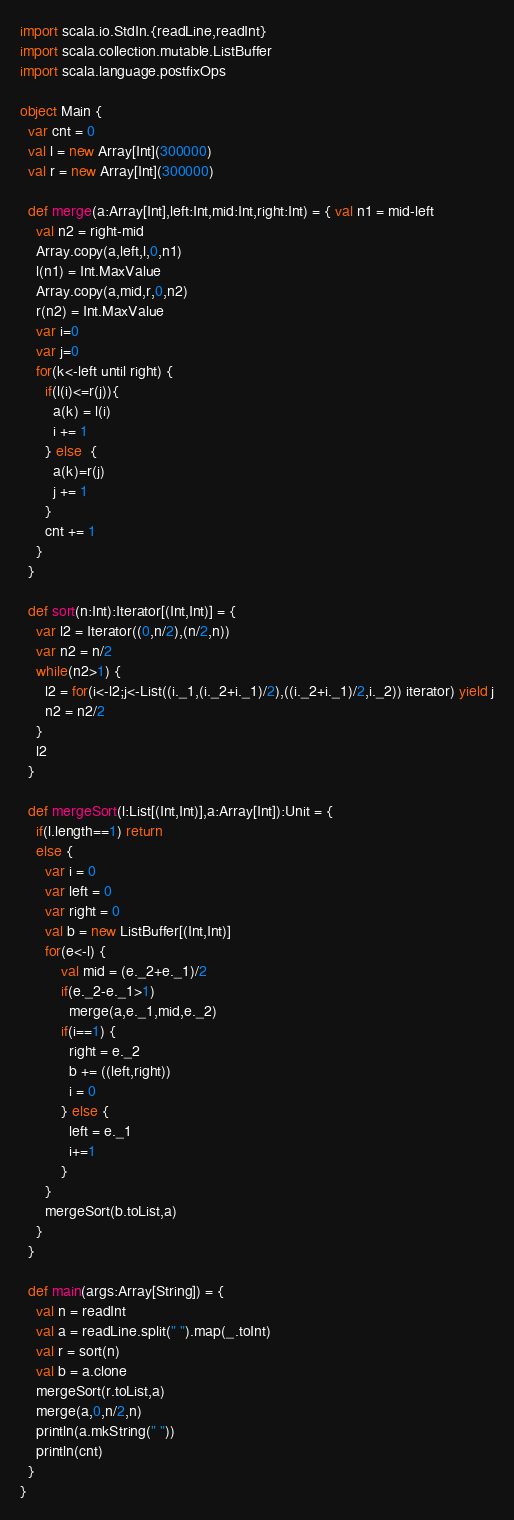<code> <loc_0><loc_0><loc_500><loc_500><_Scala_>import scala.io.StdIn.{readLine,readInt}
import scala.collection.mutable.ListBuffer
import scala.language.postfixOps

object Main {
  var cnt = 0
  val l = new Array[Int](300000)
  val r = new Array[Int](300000)

  def merge(a:Array[Int],left:Int,mid:Int,right:Int) = { val n1 = mid-left
    val n2 = right-mid
    Array.copy(a,left,l,0,n1)
    l(n1) = Int.MaxValue
    Array.copy(a,mid,r,0,n2)
    r(n2) = Int.MaxValue
    var i=0
    var j=0
    for(k<-left until right) {
      if(l(i)<=r(j)){
        a(k) = l(i)
        i += 1
      } else  {
        a(k)=r(j)
        j += 1
      }
      cnt += 1
    }
  }

  def sort(n:Int):Iterator[(Int,Int)] = {
    var l2 = Iterator((0,n/2),(n/2,n))
    var n2 = n/2
    while(n2>1) {
      l2 = for(i<-l2;j<-List((i._1,(i._2+i._1)/2),((i._2+i._1)/2,i._2)) iterator) yield j
      n2 = n2/2
    }
    l2
  }

  def mergeSort(l:List[(Int,Int)],a:Array[Int]):Unit = {
    if(l.length==1) return
    else {
      var i = 0
      var left = 0
      var right = 0
      val b = new ListBuffer[(Int,Int)]
      for(e<-l) {
          val mid = (e._2+e._1)/2
          if(e._2-e._1>1)
            merge(a,e._1,mid,e._2)
          if(i==1) {
            right = e._2
            b += ((left,right))
            i = 0
          } else {
            left = e._1
            i+=1
          }
      }
      mergeSort(b.toList,a)
    }
  }

  def main(args:Array[String]) = {
    val n = readInt
    val a = readLine.split(" ").map(_.toInt)
    val r = sort(n)
    val b = a.clone
    mergeSort(r.toList,a)
    merge(a,0,n/2,n)
    println(a.mkString(" "))
    println(cnt)
  }
}</code> 